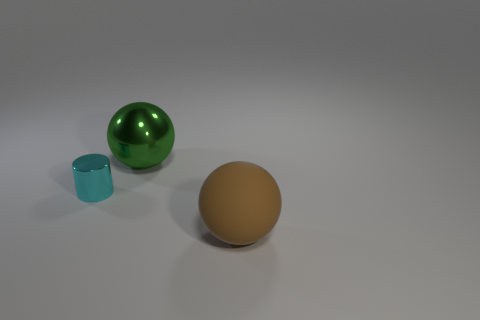What material is the large brown thing in front of the cyan object?
Give a very brief answer. Rubber. Is the shape of the green object the same as the big object in front of the small cylinder?
Keep it short and to the point. Yes. There is a object that is both to the left of the large brown sphere and to the right of the small cylinder; what is its material?
Your response must be concise. Metal. The shiny ball that is the same size as the brown matte ball is what color?
Make the answer very short. Green. Does the large green sphere have the same material as the object that is in front of the tiny cyan thing?
Provide a short and direct response. No. What number of other things are the same size as the cyan thing?
Offer a very short reply. 0. Is there a large sphere that is to the left of the thing that is right of the large sphere behind the cyan shiny object?
Your answer should be very brief. Yes. How big is the brown matte sphere?
Ensure brevity in your answer.  Large. There is a ball in front of the tiny shiny thing; what is its size?
Offer a very short reply. Large. There is a ball that is left of the brown thing; is its size the same as the brown rubber ball?
Your answer should be very brief. Yes. 